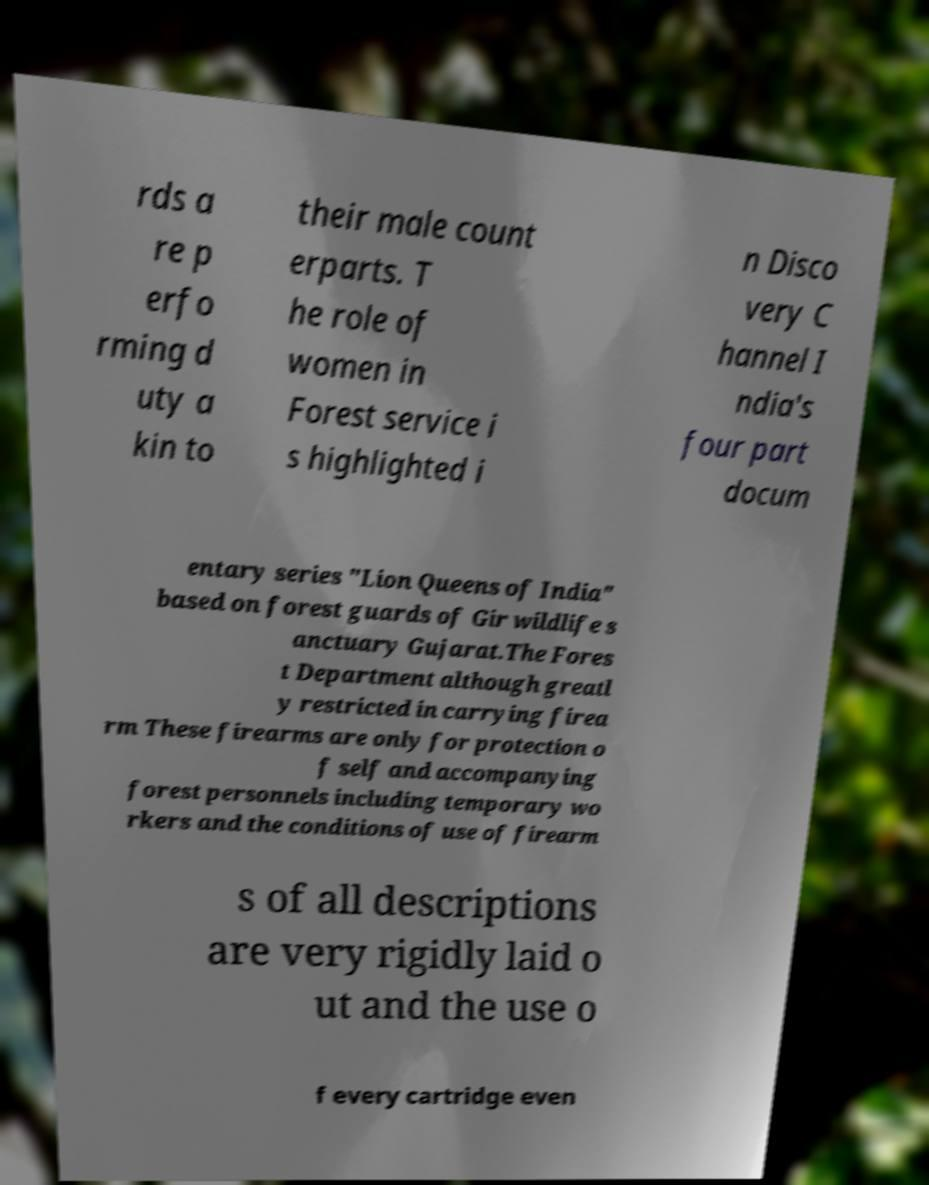Can you accurately transcribe the text from the provided image for me? rds a re p erfo rming d uty a kin to their male count erparts. T he role of women in Forest service i s highlighted i n Disco very C hannel I ndia's four part docum entary series "Lion Queens of India" based on forest guards of Gir wildlife s anctuary Gujarat.The Fores t Department although greatl y restricted in carrying firea rm These firearms are only for protection o f self and accompanying forest personnels including temporary wo rkers and the conditions of use of firearm s of all descriptions are very rigidly laid o ut and the use o f every cartridge even 